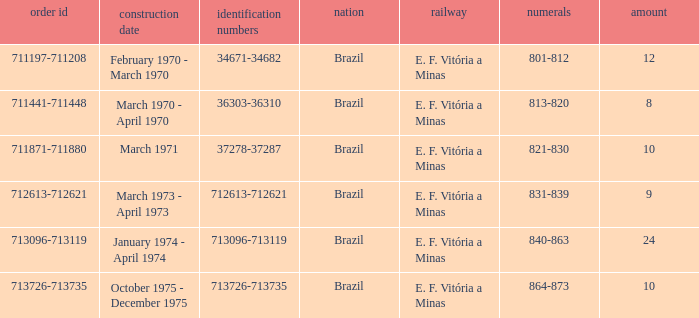What are the numbers for the order number 713096-713119? 840-863. 